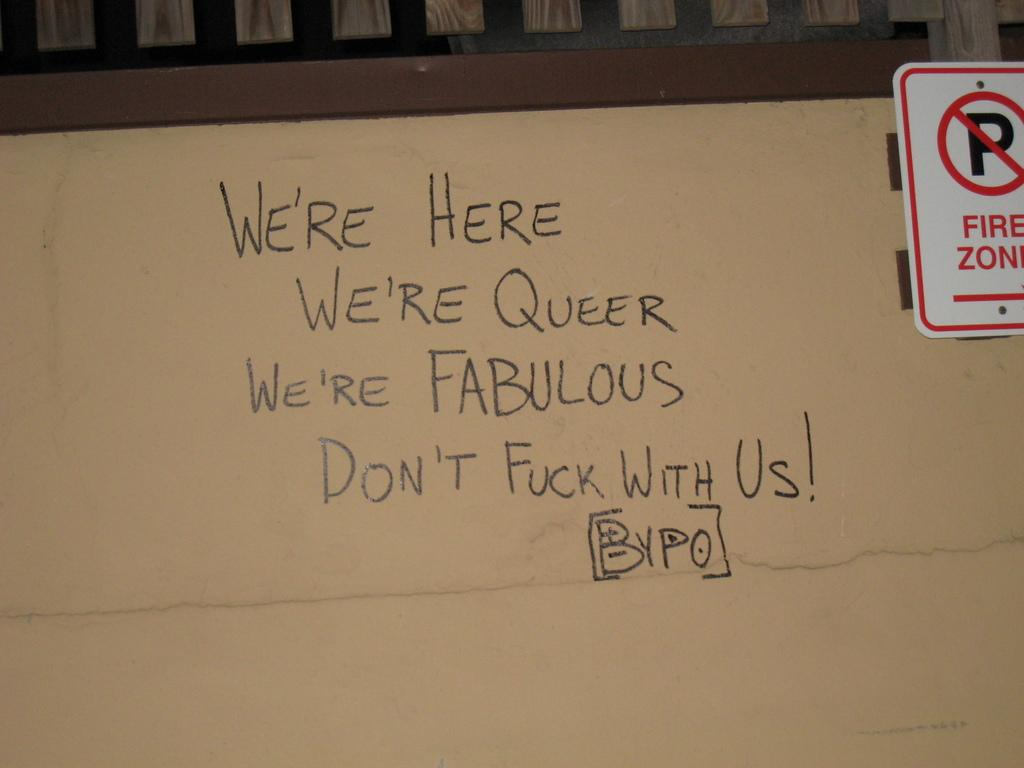<image>
Summarize the visual content of the image. Words on a board saying " We're here" next to a fire zone sign. 